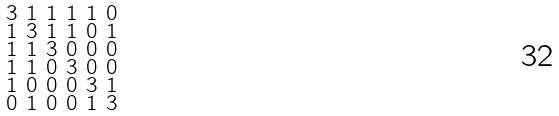Convert formula to latex. <formula><loc_0><loc_0><loc_500><loc_500>\begin{smallmatrix} 3 & 1 & 1 & 1 & 1 & 0 \\ 1 & 3 & 1 & 1 & 0 & 1 \\ 1 & 1 & 3 & 0 & 0 & 0 \\ 1 & 1 & 0 & 3 & 0 & 0 \\ 1 & 0 & 0 & 0 & 3 & 1 \\ 0 & 1 & 0 & 0 & 1 & 3 \end{smallmatrix}</formula> 